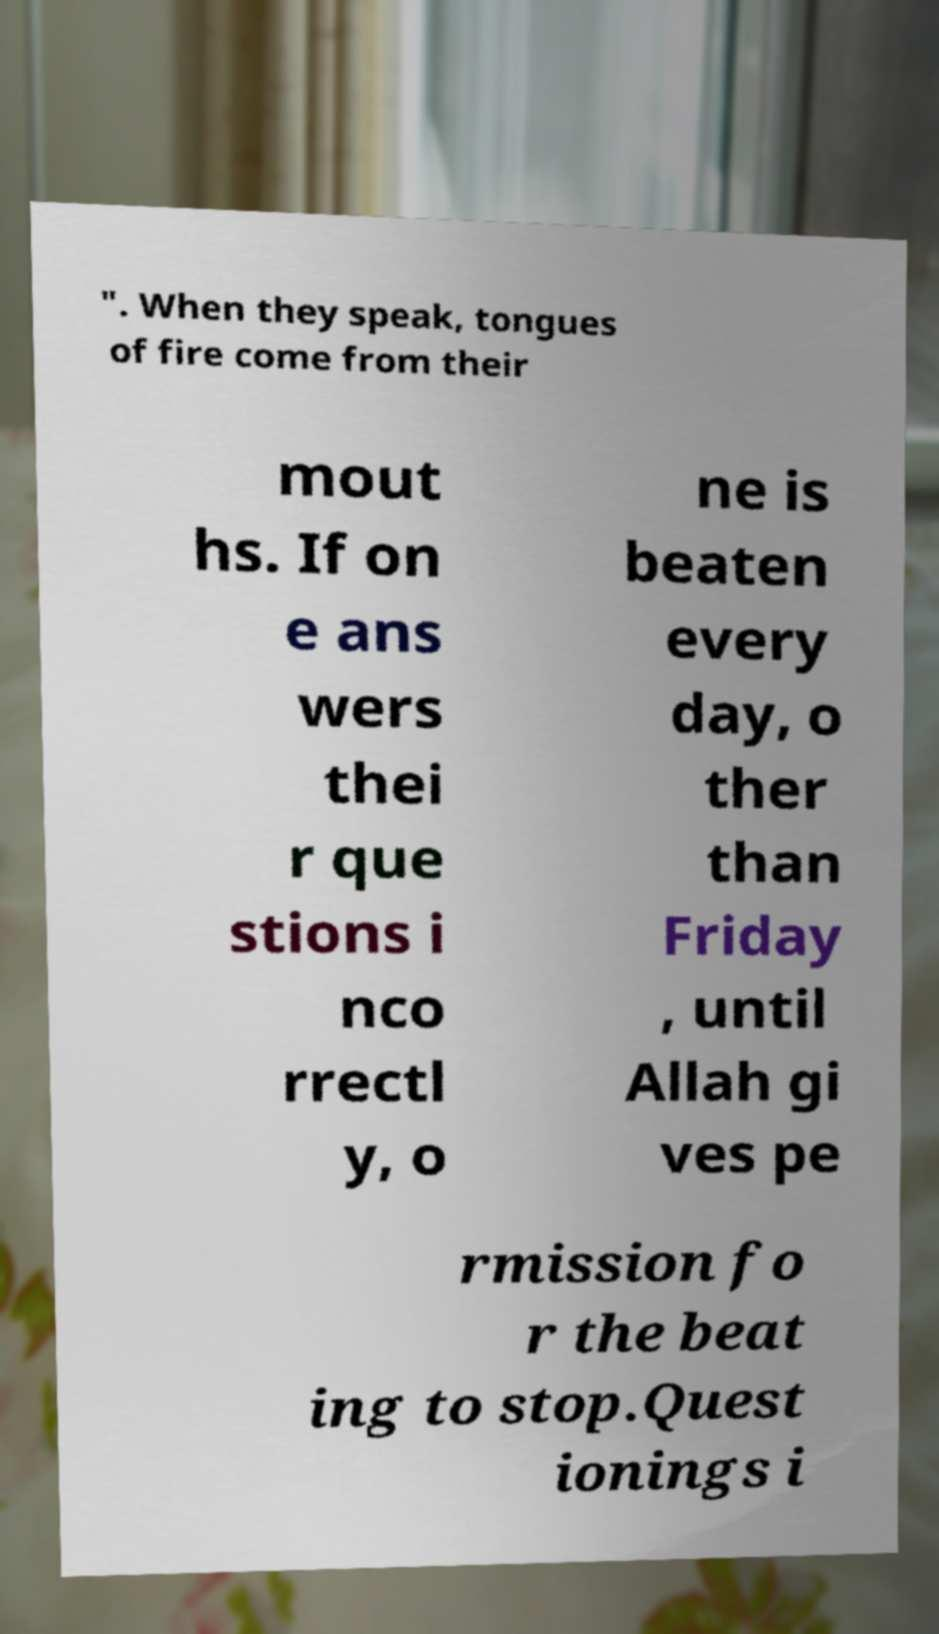Can you read and provide the text displayed in the image?This photo seems to have some interesting text. Can you extract and type it out for me? ". When they speak, tongues of fire come from their mout hs. If on e ans wers thei r que stions i nco rrectl y, o ne is beaten every day, o ther than Friday , until Allah gi ves pe rmission fo r the beat ing to stop.Quest ionings i 